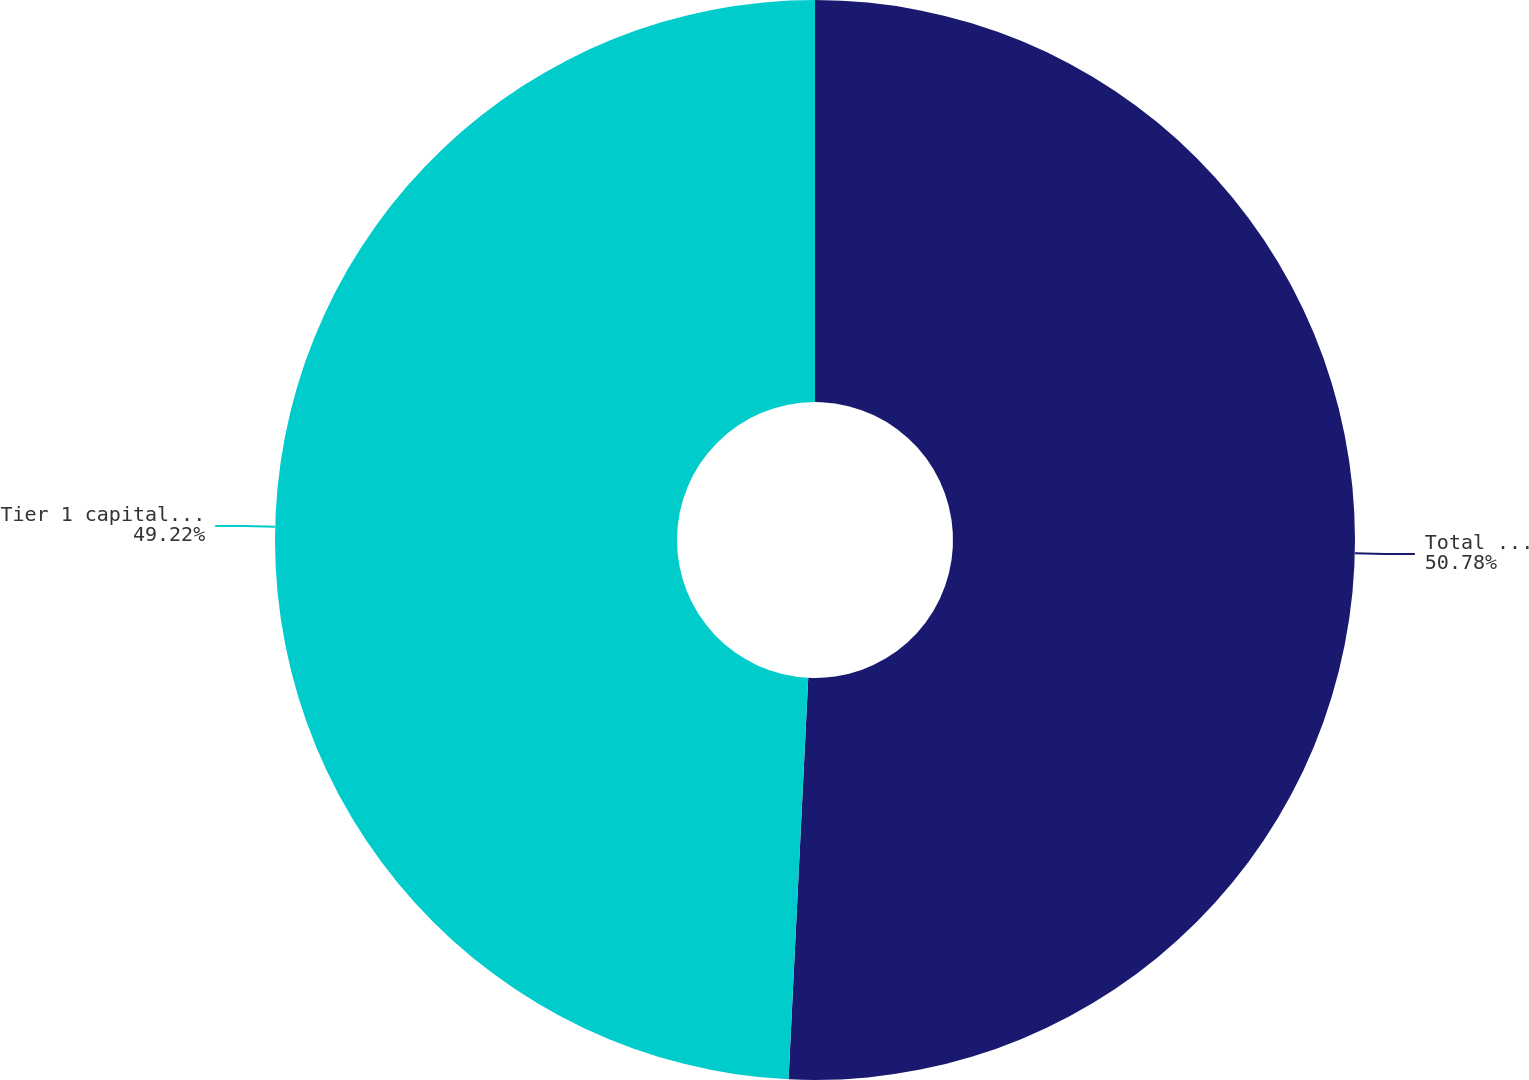Convert chart to OTSL. <chart><loc_0><loc_0><loc_500><loc_500><pie_chart><fcel>Total risk-based capital ratio<fcel>Tier 1 capital ratio<nl><fcel>50.78%<fcel>49.22%<nl></chart> 